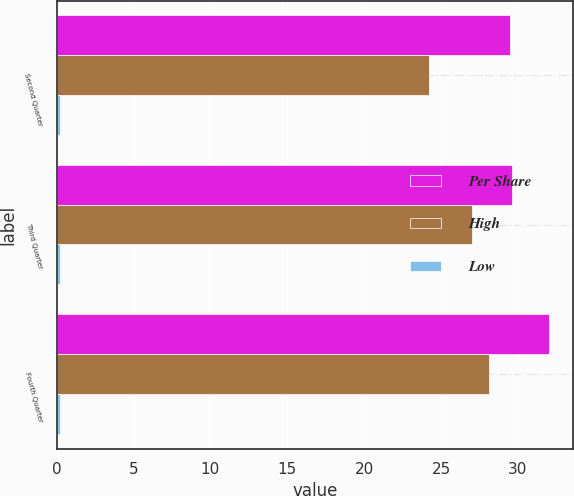Convert chart to OTSL. <chart><loc_0><loc_0><loc_500><loc_500><stacked_bar_chart><ecel><fcel>Second Quarter<fcel>Third Quarter<fcel>Fourth Quarter<nl><fcel>Per Share<fcel>29.48<fcel>29.58<fcel>31.99<nl><fcel>High<fcel>24.24<fcel>26.99<fcel>28.13<nl><fcel>Low<fcel>0.25<fcel>0.25<fcel>0.25<nl></chart> 